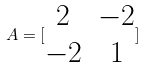Convert formula to latex. <formula><loc_0><loc_0><loc_500><loc_500>A = [ \begin{matrix} 2 & - 2 \\ - 2 & 1 \end{matrix} ]</formula> 